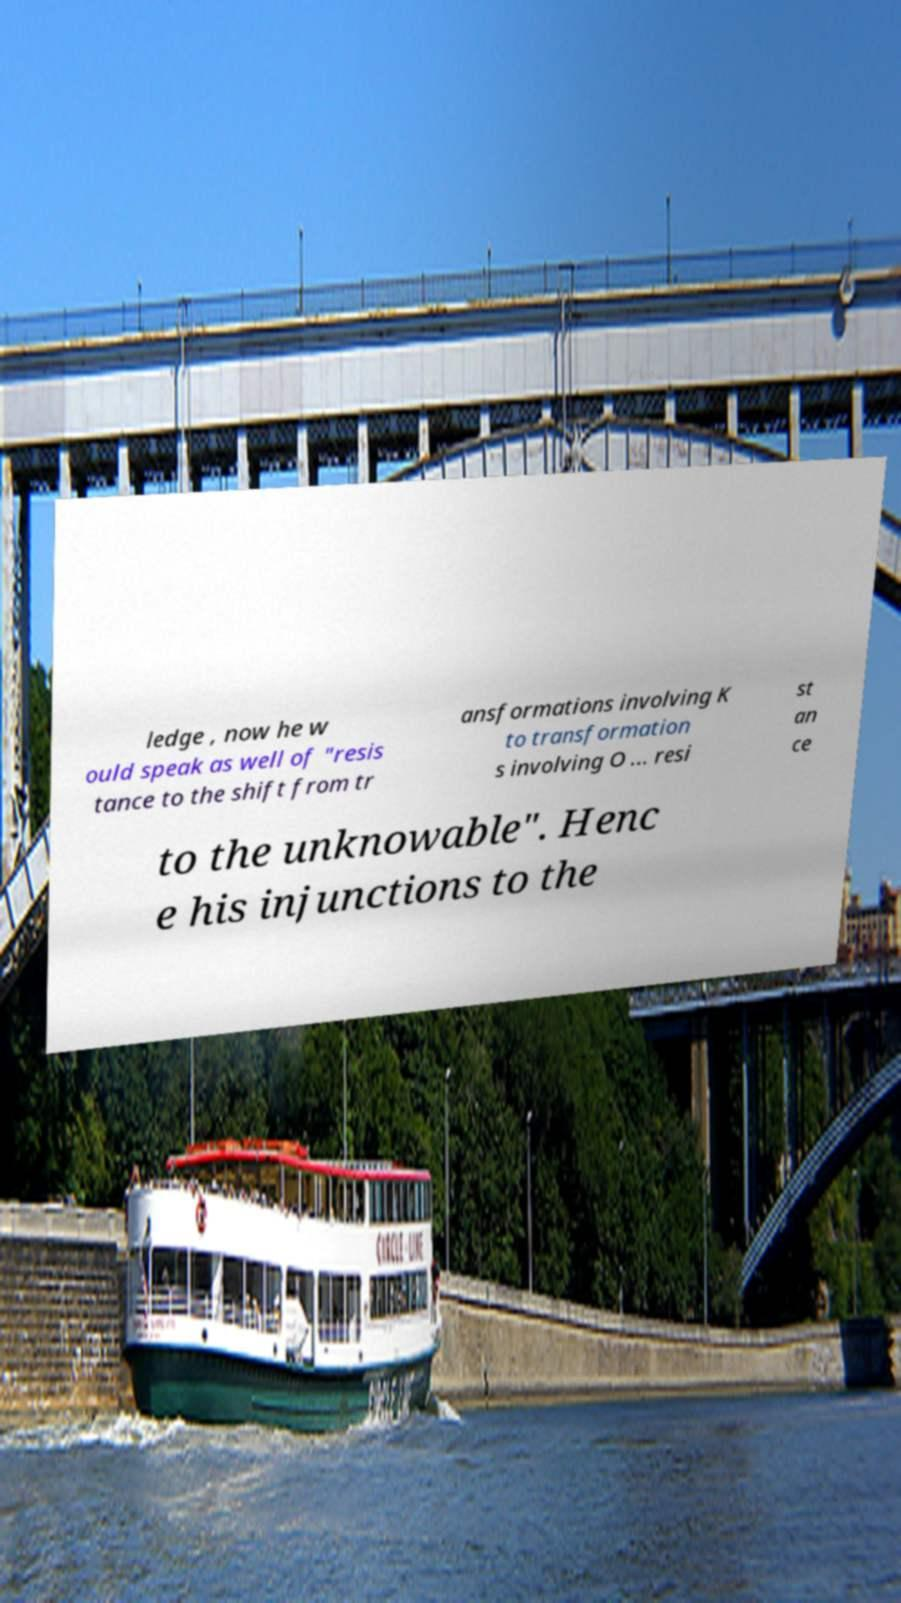There's text embedded in this image that I need extracted. Can you transcribe it verbatim? ledge , now he w ould speak as well of "resis tance to the shift from tr ansformations involving K to transformation s involving O ... resi st an ce to the unknowable". Henc e his injunctions to the 